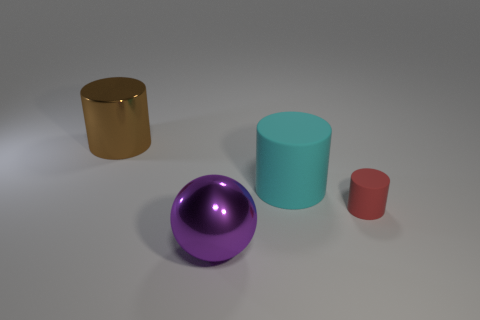What is the size of the shiny ball?
Offer a very short reply. Large. Are there more large things to the right of the purple object than purple balls that are on the right side of the red matte object?
Your answer should be very brief. Yes. Is the number of blue metal objects greater than the number of big matte cylinders?
Make the answer very short. No. What is the size of the object that is to the left of the large cyan thing and on the right side of the brown object?
Keep it short and to the point. Large. There is a purple thing; what shape is it?
Provide a short and direct response. Sphere. Is there anything else that is the same size as the red thing?
Provide a succinct answer. No. Is the number of big metallic balls that are behind the small thing greater than the number of small cylinders?
Your response must be concise. No. What shape is the big thing that is on the right side of the shiny thing in front of the big metallic object that is behind the large purple thing?
Provide a short and direct response. Cylinder. Does the metallic thing right of the brown object have the same size as the big cyan object?
Ensure brevity in your answer.  Yes. There is a object that is behind the red object and to the left of the large cyan matte thing; what is its shape?
Your answer should be very brief. Cylinder. 